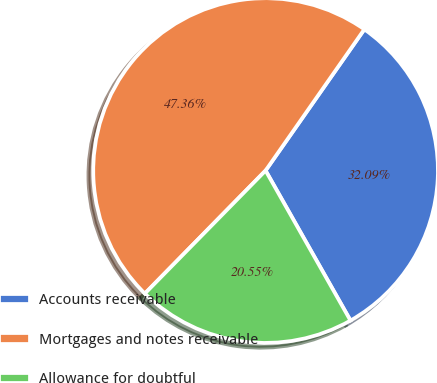<chart> <loc_0><loc_0><loc_500><loc_500><pie_chart><fcel>Accounts receivable<fcel>Mortgages and notes receivable<fcel>Allowance for doubtful<nl><fcel>32.09%<fcel>47.36%<fcel>20.55%<nl></chart> 